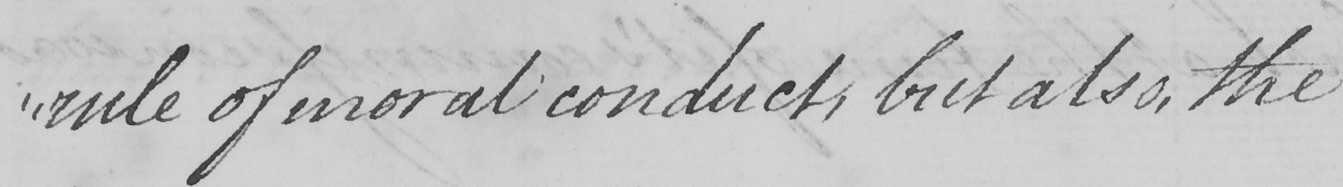Please transcribe the handwritten text in this image. " rule of moral conduct , but also , the  _ 